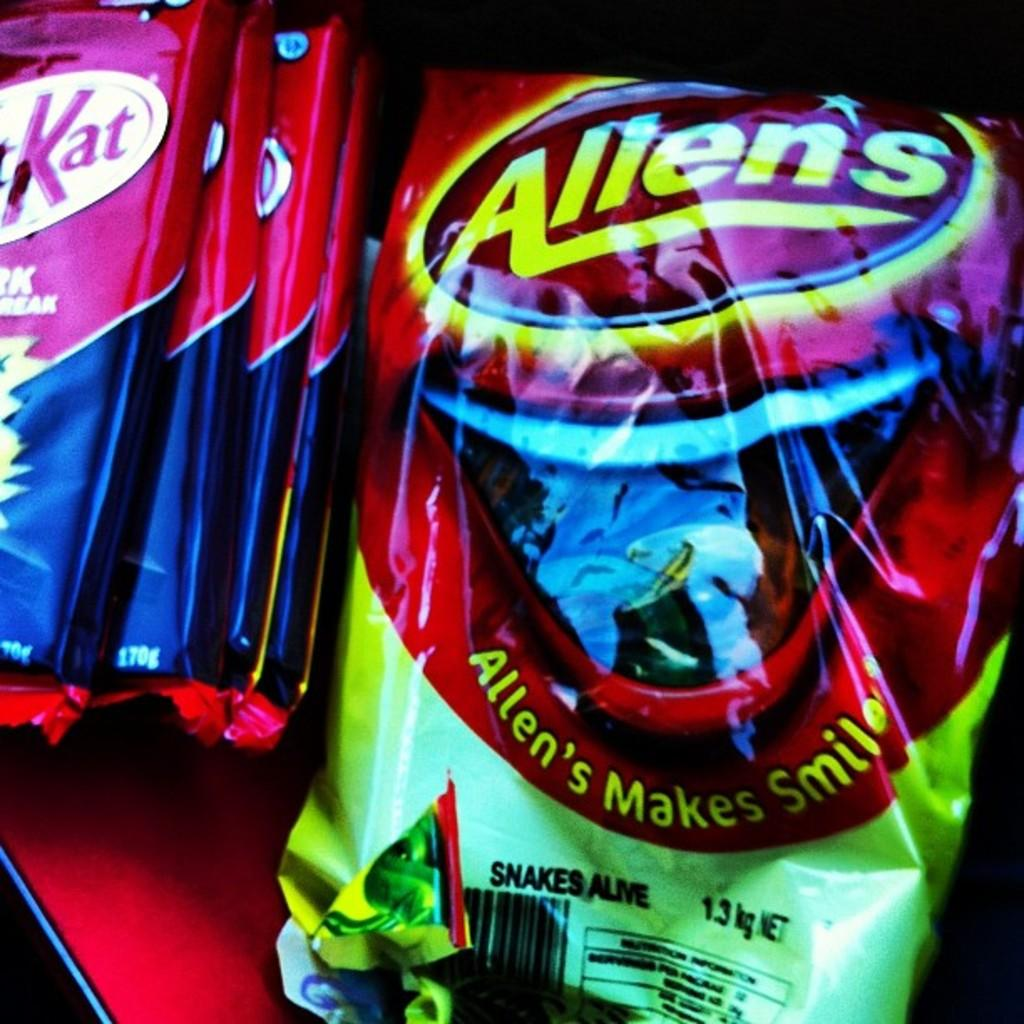What type of food is present in the image? There is chocolate in the image. What else can be seen on the table besides the chocolate? There are packets on the table. Where are the chocolate and packets located in the image? The chocolate and packets are placed on a table. What page of the calendar is open in the image? There is no calendar present in the image, so it is not possible to determine which page might be open. 